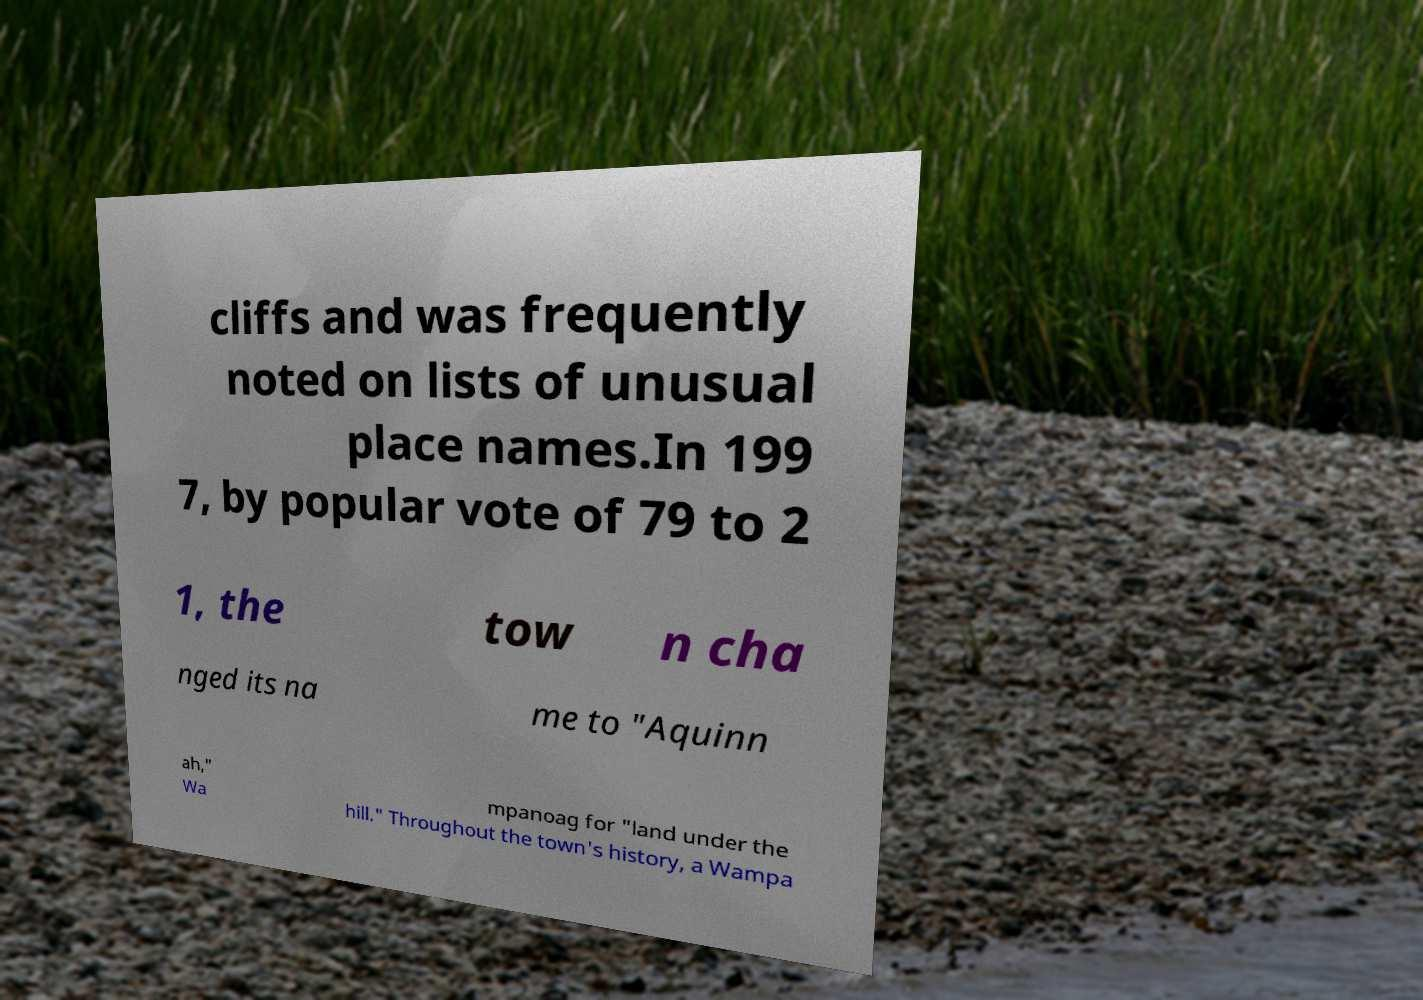Please identify and transcribe the text found in this image. cliffs and was frequently noted on lists of unusual place names.In 199 7, by popular vote of 79 to 2 1, the tow n cha nged its na me to "Aquinn ah," Wa mpanoag for "land under the hill." Throughout the town's history, a Wampa 